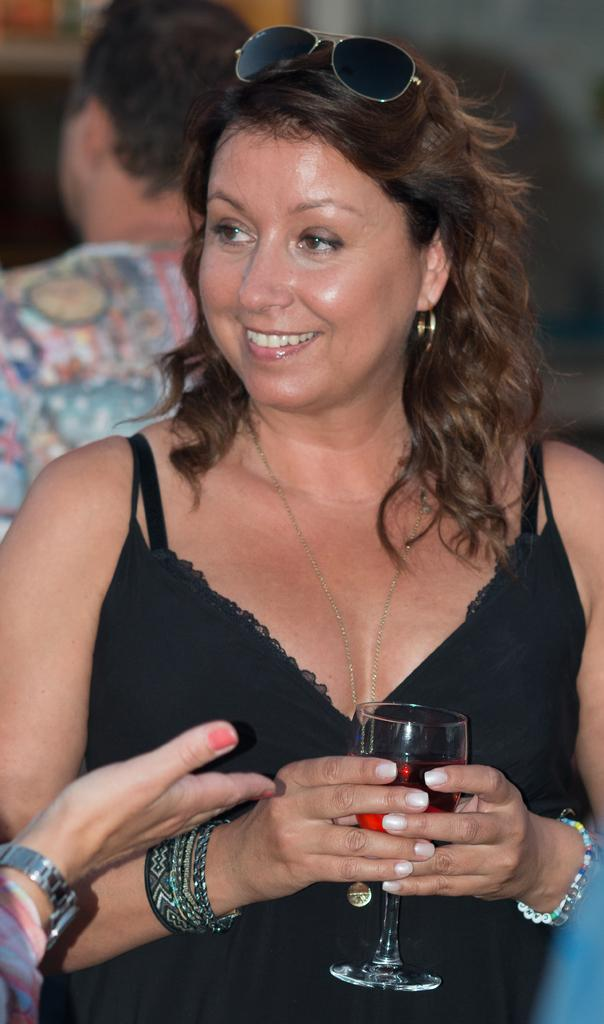Who is the main subject in the image? There is a woman in the image. What is the woman holding in the image? The woman is holding a glass. What accessory is the woman wearing in the image? The woman is wearing goggles on her head. What type of map can be seen in the image? There is no map present in the image. How many ladybugs are on the woman's shoulder in the image? There are no ladybugs present in the image. 